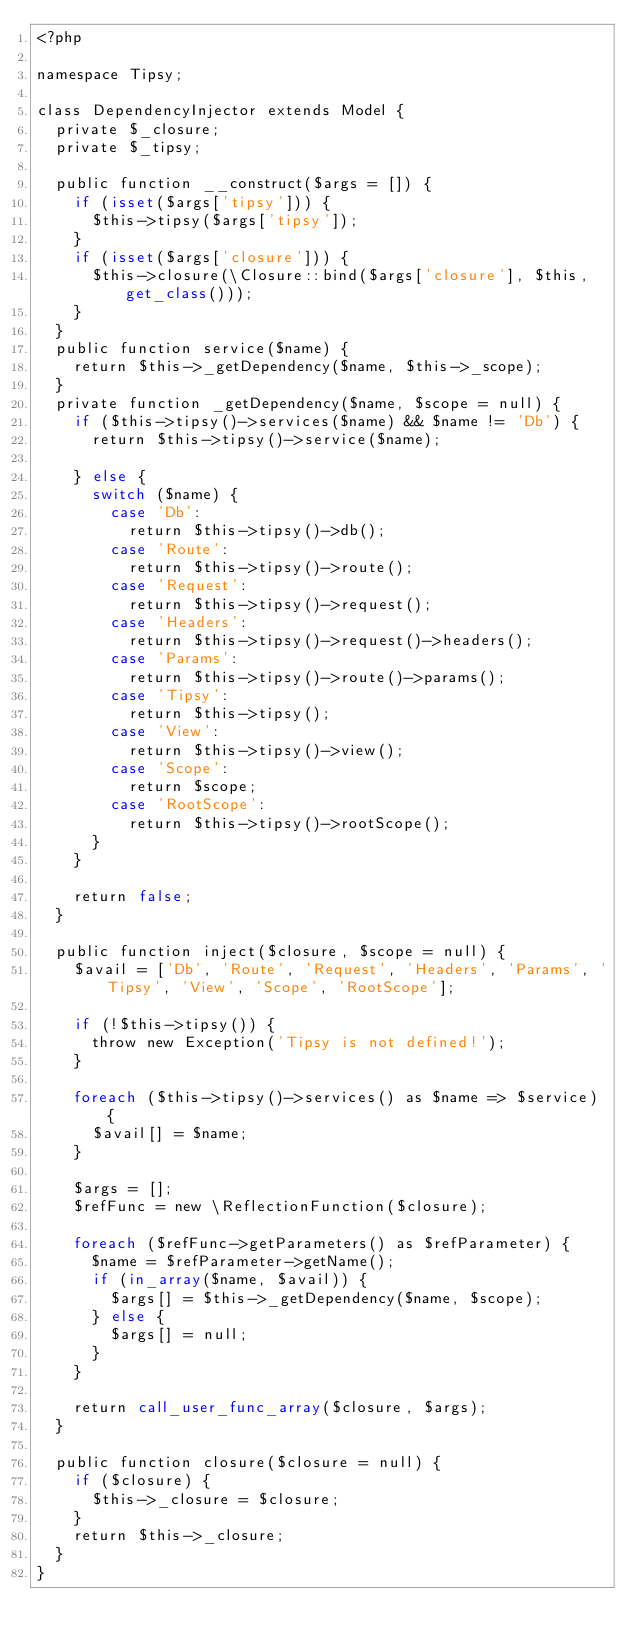<code> <loc_0><loc_0><loc_500><loc_500><_PHP_><?php

namespace Tipsy;

class DependencyInjector extends Model {
	private $_closure;
	private $_tipsy;

	public function __construct($args = []) {
		if (isset($args['tipsy'])) {
			$this->tipsy($args['tipsy']);
		}
		if (isset($args['closure'])) {
			$this->closure(\Closure::bind($args['closure'], $this, get_class()));
		}
	}
	public function service($name) {
		return $this->_getDependency($name, $this->_scope);
	}
	private function _getDependency($name, $scope = null) {
		if ($this->tipsy()->services($name) && $name != 'Db') {
			return $this->tipsy()->service($name);

		} else {
			switch ($name) {
				case 'Db':
					return $this->tipsy()->db();
				case 'Route':
					return $this->tipsy()->route();
				case 'Request':
					return $this->tipsy()->request();
				case 'Headers':
					return $this->tipsy()->request()->headers();
				case 'Params':
					return $this->tipsy()->route()->params();
				case 'Tipsy':
					return $this->tipsy();
				case 'View':
					return $this->tipsy()->view();
				case 'Scope':
					return $scope;
				case 'RootScope':
					return $this->tipsy()->rootScope();
			}
		}

		return false;
	}

	public function inject($closure, $scope = null) {
		$avail = ['Db', 'Route', 'Request', 'Headers', 'Params', 'Tipsy', 'View', 'Scope', 'RootScope'];

		if (!$this->tipsy()) {
			throw new Exception('Tipsy is not defined!');
		}

		foreach ($this->tipsy()->services() as $name => $service) {
			$avail[] = $name;
		}

		$args = [];
		$refFunc = new \ReflectionFunction($closure);

		foreach ($refFunc->getParameters() as $refParameter) {
			$name = $refParameter->getName();
			if (in_array($name, $avail)) {
				$args[] = $this->_getDependency($name, $scope);
			} else {
				$args[] = null;
			}
		}

		return call_user_func_array($closure, $args);
	}

	public function closure($closure = null) {
		if ($closure) {
			$this->_closure = $closure;
		}
		return $this->_closure;
	}
}
</code> 